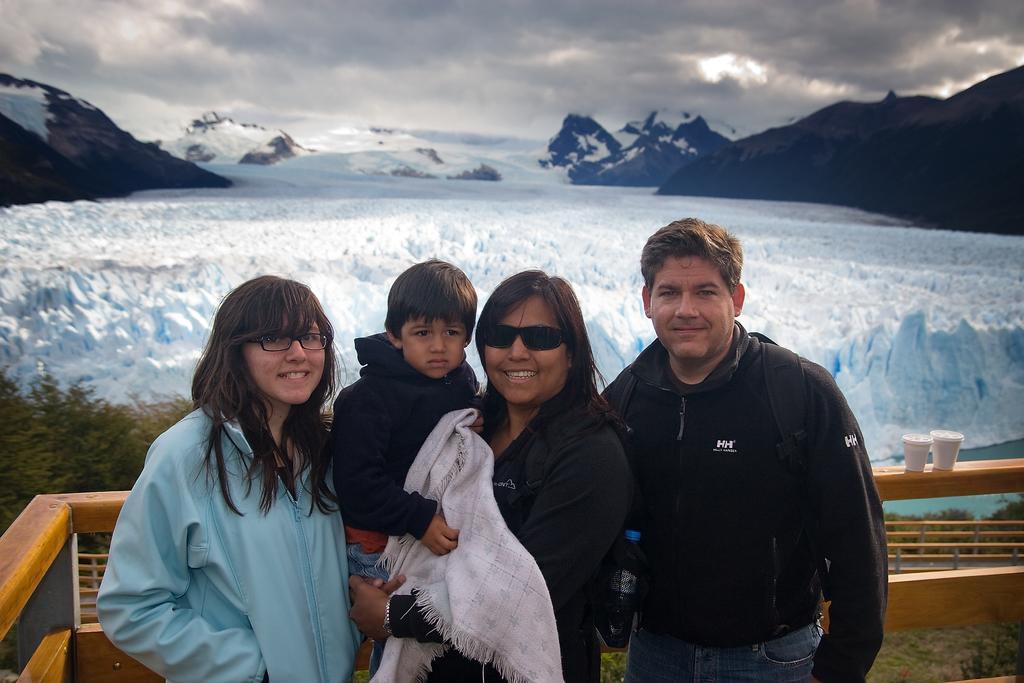Describe this image in one or two sentences. In the picture we can see a man, woman, girl and boy and woman is holding a boy and they are standing on the path and around them, we can see a railing on it, we can see two glasses and behind the railing we can see some plants and snow surface and on both sides of the surface we can see hills and in the background we can see a sky with clouds. 